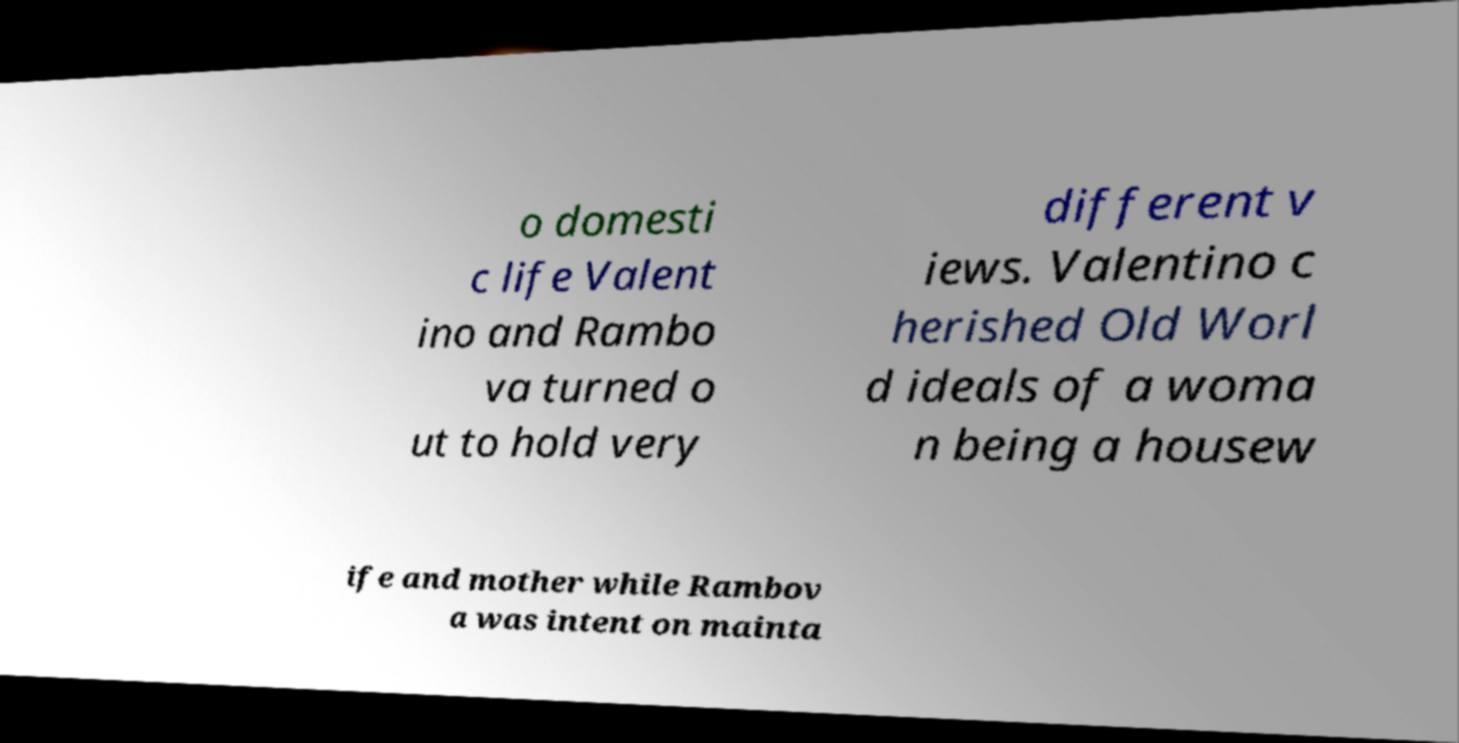Can you read and provide the text displayed in the image?This photo seems to have some interesting text. Can you extract and type it out for me? o domesti c life Valent ino and Rambo va turned o ut to hold very different v iews. Valentino c herished Old Worl d ideals of a woma n being a housew ife and mother while Rambov a was intent on mainta 